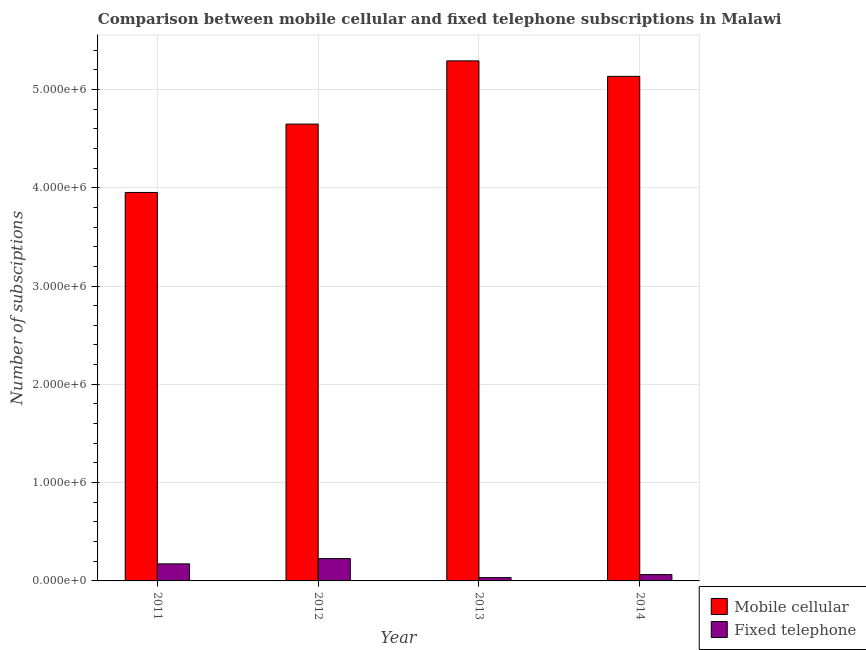How many groups of bars are there?
Your answer should be very brief. 4. What is the label of the 3rd group of bars from the left?
Provide a short and direct response. 2013. In how many cases, is the number of bars for a given year not equal to the number of legend labels?
Keep it short and to the point. 0. What is the number of fixed telephone subscriptions in 2014?
Provide a short and direct response. 6.42e+04. Across all years, what is the maximum number of mobile cellular subscriptions?
Offer a very short reply. 5.29e+06. Across all years, what is the minimum number of mobile cellular subscriptions?
Provide a succinct answer. 3.95e+06. What is the total number of mobile cellular subscriptions in the graph?
Keep it short and to the point. 1.90e+07. What is the difference between the number of fixed telephone subscriptions in 2011 and that in 2013?
Keep it short and to the point. 1.40e+05. What is the difference between the number of fixed telephone subscriptions in 2011 and the number of mobile cellular subscriptions in 2014?
Provide a short and direct response. 1.09e+05. What is the average number of mobile cellular subscriptions per year?
Give a very brief answer. 4.76e+06. In the year 2011, what is the difference between the number of fixed telephone subscriptions and number of mobile cellular subscriptions?
Provide a short and direct response. 0. What is the ratio of the number of fixed telephone subscriptions in 2012 to that in 2013?
Your answer should be compact. 6.77. Is the number of fixed telephone subscriptions in 2011 less than that in 2014?
Keep it short and to the point. No. Is the difference between the number of mobile cellular subscriptions in 2011 and 2014 greater than the difference between the number of fixed telephone subscriptions in 2011 and 2014?
Make the answer very short. No. What is the difference between the highest and the second highest number of fixed telephone subscriptions?
Make the answer very short. 5.38e+04. What is the difference between the highest and the lowest number of fixed telephone subscriptions?
Keep it short and to the point. 1.94e+05. Is the sum of the number of mobile cellular subscriptions in 2012 and 2013 greater than the maximum number of fixed telephone subscriptions across all years?
Offer a very short reply. Yes. What does the 2nd bar from the left in 2011 represents?
Your answer should be compact. Fixed telephone. What does the 2nd bar from the right in 2011 represents?
Provide a short and direct response. Mobile cellular. How many bars are there?
Your answer should be compact. 8. How many years are there in the graph?
Offer a terse response. 4. Are the values on the major ticks of Y-axis written in scientific E-notation?
Offer a terse response. Yes. Does the graph contain any zero values?
Make the answer very short. No. Does the graph contain grids?
Your answer should be very brief. Yes. How many legend labels are there?
Your response must be concise. 2. What is the title of the graph?
Your answer should be compact. Comparison between mobile cellular and fixed telephone subscriptions in Malawi. What is the label or title of the X-axis?
Give a very brief answer. Year. What is the label or title of the Y-axis?
Your answer should be compact. Number of subsciptions. What is the Number of subsciptions of Mobile cellular in 2011?
Ensure brevity in your answer.  3.95e+06. What is the Number of subsciptions in Fixed telephone in 2011?
Your answer should be compact. 1.73e+05. What is the Number of subsciptions of Mobile cellular in 2012?
Ensure brevity in your answer.  4.65e+06. What is the Number of subsciptions of Fixed telephone in 2012?
Keep it short and to the point. 2.27e+05. What is the Number of subsciptions of Mobile cellular in 2013?
Provide a short and direct response. 5.29e+06. What is the Number of subsciptions in Fixed telephone in 2013?
Keep it short and to the point. 3.36e+04. What is the Number of subsciptions in Mobile cellular in 2014?
Your response must be concise. 5.13e+06. What is the Number of subsciptions of Fixed telephone in 2014?
Offer a terse response. 6.42e+04. Across all years, what is the maximum Number of subsciptions in Mobile cellular?
Keep it short and to the point. 5.29e+06. Across all years, what is the maximum Number of subsciptions of Fixed telephone?
Make the answer very short. 2.27e+05. Across all years, what is the minimum Number of subsciptions in Mobile cellular?
Your answer should be very brief. 3.95e+06. Across all years, what is the minimum Number of subsciptions of Fixed telephone?
Offer a terse response. 3.36e+04. What is the total Number of subsciptions in Mobile cellular in the graph?
Give a very brief answer. 1.90e+07. What is the total Number of subsciptions in Fixed telephone in the graph?
Offer a terse response. 4.99e+05. What is the difference between the Number of subsciptions in Mobile cellular in 2011 and that in 2012?
Offer a very short reply. -6.95e+05. What is the difference between the Number of subsciptions of Fixed telephone in 2011 and that in 2012?
Offer a very short reply. -5.38e+04. What is the difference between the Number of subsciptions in Mobile cellular in 2011 and that in 2013?
Your response must be concise. -1.34e+06. What is the difference between the Number of subsciptions in Fixed telephone in 2011 and that in 2013?
Offer a terse response. 1.40e+05. What is the difference between the Number of subsciptions of Mobile cellular in 2011 and that in 2014?
Make the answer very short. -1.18e+06. What is the difference between the Number of subsciptions of Fixed telephone in 2011 and that in 2014?
Offer a terse response. 1.09e+05. What is the difference between the Number of subsciptions in Mobile cellular in 2012 and that in 2013?
Your answer should be compact. -6.43e+05. What is the difference between the Number of subsciptions in Fixed telephone in 2012 and that in 2013?
Provide a succinct answer. 1.94e+05. What is the difference between the Number of subsciptions of Mobile cellular in 2012 and that in 2014?
Offer a terse response. -4.86e+05. What is the difference between the Number of subsciptions in Fixed telephone in 2012 and that in 2014?
Your response must be concise. 1.63e+05. What is the difference between the Number of subsciptions in Mobile cellular in 2013 and that in 2014?
Your answer should be very brief. 1.58e+05. What is the difference between the Number of subsciptions of Fixed telephone in 2013 and that in 2014?
Offer a very short reply. -3.07e+04. What is the difference between the Number of subsciptions in Mobile cellular in 2011 and the Number of subsciptions in Fixed telephone in 2012?
Your answer should be very brief. 3.72e+06. What is the difference between the Number of subsciptions of Mobile cellular in 2011 and the Number of subsciptions of Fixed telephone in 2013?
Give a very brief answer. 3.92e+06. What is the difference between the Number of subsciptions in Mobile cellular in 2011 and the Number of subsciptions in Fixed telephone in 2014?
Your answer should be very brief. 3.89e+06. What is the difference between the Number of subsciptions of Mobile cellular in 2012 and the Number of subsciptions of Fixed telephone in 2013?
Offer a very short reply. 4.61e+06. What is the difference between the Number of subsciptions of Mobile cellular in 2012 and the Number of subsciptions of Fixed telephone in 2014?
Your answer should be compact. 4.58e+06. What is the difference between the Number of subsciptions of Mobile cellular in 2013 and the Number of subsciptions of Fixed telephone in 2014?
Make the answer very short. 5.23e+06. What is the average Number of subsciptions of Mobile cellular per year?
Offer a very short reply. 4.76e+06. What is the average Number of subsciptions in Fixed telephone per year?
Offer a terse response. 1.25e+05. In the year 2011, what is the difference between the Number of subsciptions in Mobile cellular and Number of subsciptions in Fixed telephone?
Offer a very short reply. 3.78e+06. In the year 2012, what is the difference between the Number of subsciptions in Mobile cellular and Number of subsciptions in Fixed telephone?
Offer a very short reply. 4.42e+06. In the year 2013, what is the difference between the Number of subsciptions in Mobile cellular and Number of subsciptions in Fixed telephone?
Keep it short and to the point. 5.26e+06. In the year 2014, what is the difference between the Number of subsciptions of Mobile cellular and Number of subsciptions of Fixed telephone?
Offer a terse response. 5.07e+06. What is the ratio of the Number of subsciptions of Mobile cellular in 2011 to that in 2012?
Your response must be concise. 0.85. What is the ratio of the Number of subsciptions of Fixed telephone in 2011 to that in 2012?
Provide a short and direct response. 0.76. What is the ratio of the Number of subsciptions of Mobile cellular in 2011 to that in 2013?
Your response must be concise. 0.75. What is the ratio of the Number of subsciptions in Fixed telephone in 2011 to that in 2013?
Provide a succinct answer. 5.17. What is the ratio of the Number of subsciptions of Mobile cellular in 2011 to that in 2014?
Ensure brevity in your answer.  0.77. What is the ratio of the Number of subsciptions in Fixed telephone in 2011 to that in 2014?
Provide a succinct answer. 2.7. What is the ratio of the Number of subsciptions of Mobile cellular in 2012 to that in 2013?
Your response must be concise. 0.88. What is the ratio of the Number of subsciptions of Fixed telephone in 2012 to that in 2013?
Your answer should be compact. 6.77. What is the ratio of the Number of subsciptions of Mobile cellular in 2012 to that in 2014?
Your response must be concise. 0.91. What is the ratio of the Number of subsciptions of Fixed telephone in 2012 to that in 2014?
Offer a terse response. 3.54. What is the ratio of the Number of subsciptions in Mobile cellular in 2013 to that in 2014?
Make the answer very short. 1.03. What is the ratio of the Number of subsciptions in Fixed telephone in 2013 to that in 2014?
Make the answer very short. 0.52. What is the difference between the highest and the second highest Number of subsciptions of Mobile cellular?
Offer a very short reply. 1.58e+05. What is the difference between the highest and the second highest Number of subsciptions in Fixed telephone?
Offer a very short reply. 5.38e+04. What is the difference between the highest and the lowest Number of subsciptions of Mobile cellular?
Provide a short and direct response. 1.34e+06. What is the difference between the highest and the lowest Number of subsciptions in Fixed telephone?
Offer a terse response. 1.94e+05. 